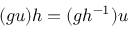Convert formula to latex. <formula><loc_0><loc_0><loc_500><loc_500>( g u ) h = ( g h ^ { - 1 } ) u</formula> 